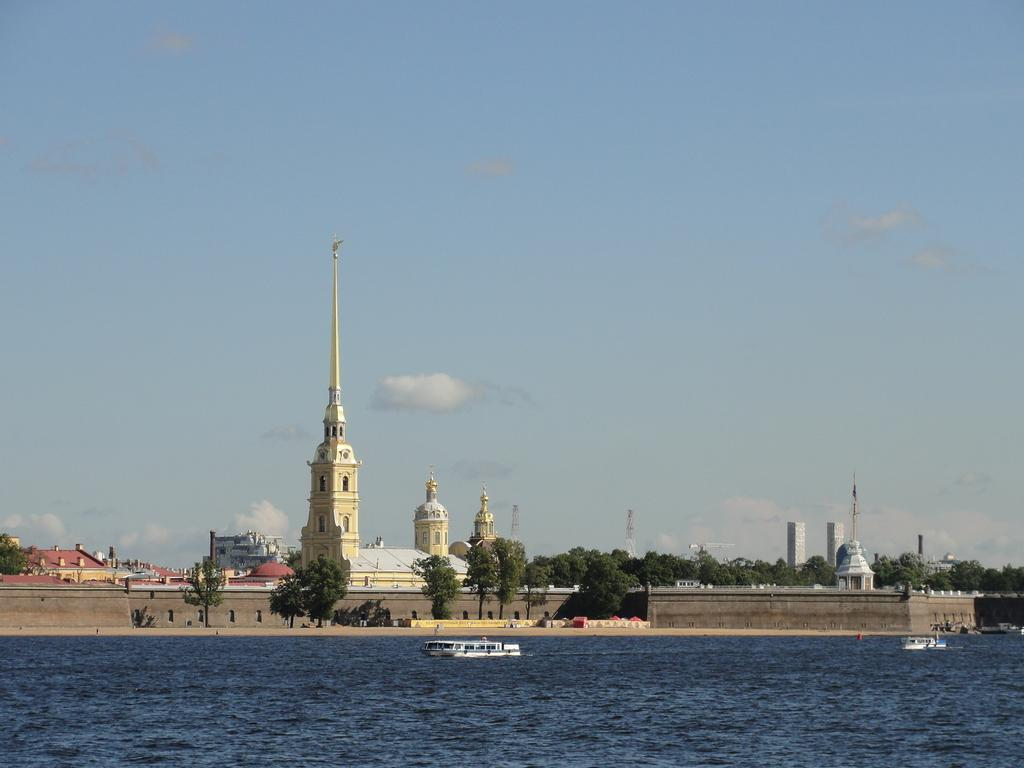What is in the water in the image? There are boats in the water in the image. What can be seen in the background of the image? There are trees, buildings, and the sky visible in the background of the image. What type of string is being used to copy the trees in the image? There is no string or copying activity present in the image; it features boats in the water and trees, buildings, and the sky in the background. 